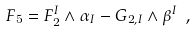Convert formula to latex. <formula><loc_0><loc_0><loc_500><loc_500>F _ { 5 } = F _ { 2 } ^ { I } \wedge \alpha _ { I } - G _ { 2 , I } \wedge \beta ^ { I } \ ,</formula> 